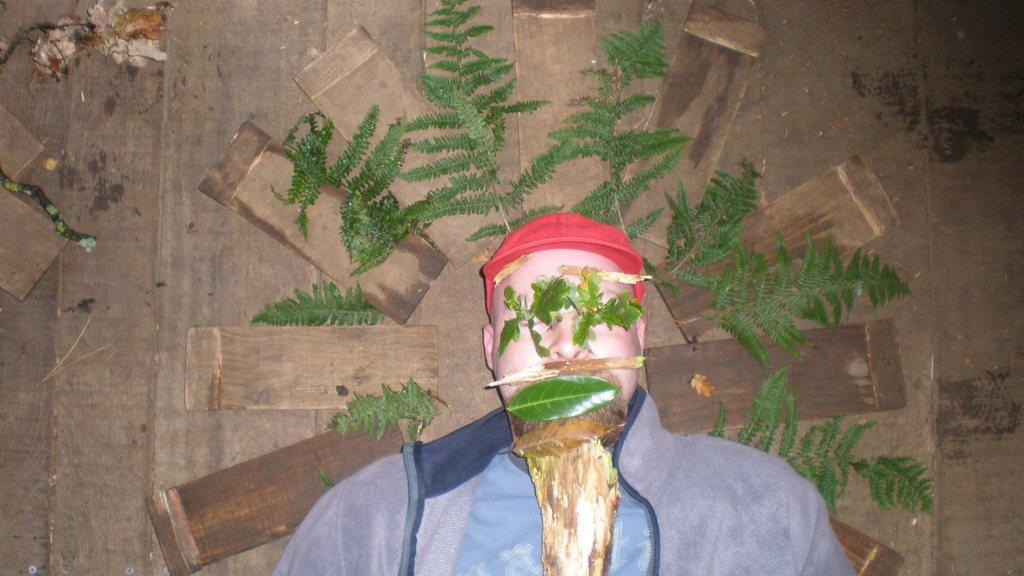What is the man doing in the image? The man is lying on the wooden floor in the image. What type of material is the floor made of? The floor is made of wood. Can you describe any other elements in the image besides the man? Yes, there are green leaves visible in the image. What type of debt is the man discussing with the leaves in the image? There is no indication of a debt or any discussion in the image; it simply shows a man lying on the wooden floor and green leaves. 